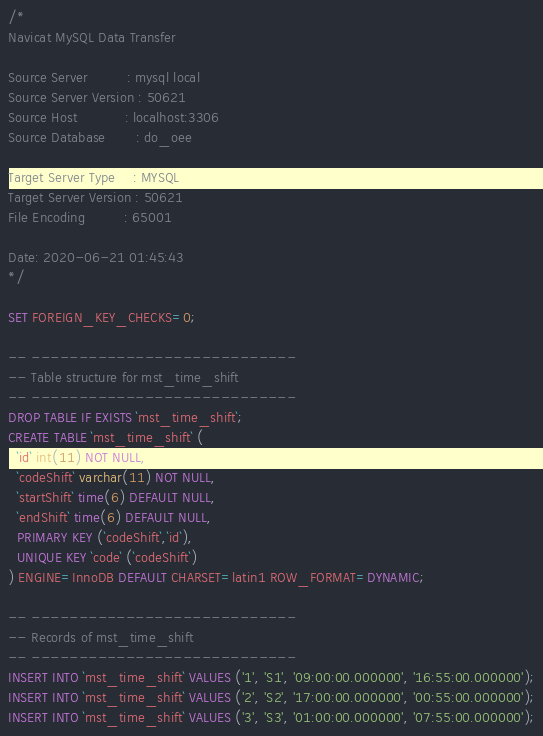Convert code to text. <code><loc_0><loc_0><loc_500><loc_500><_SQL_>/*
Navicat MySQL Data Transfer

Source Server         : mysql local
Source Server Version : 50621
Source Host           : localhost:3306
Source Database       : do_oee

Target Server Type    : MYSQL
Target Server Version : 50621
File Encoding         : 65001

Date: 2020-06-21 01:45:43
*/

SET FOREIGN_KEY_CHECKS=0;

-- ----------------------------
-- Table structure for mst_time_shift
-- ----------------------------
DROP TABLE IF EXISTS `mst_time_shift`;
CREATE TABLE `mst_time_shift` (
  `id` int(11) NOT NULL,
  `codeShift` varchar(11) NOT NULL,
  `startShift` time(6) DEFAULT NULL,
  `endShift` time(6) DEFAULT NULL,
  PRIMARY KEY (`codeShift`,`id`),
  UNIQUE KEY `code` (`codeShift`)
) ENGINE=InnoDB DEFAULT CHARSET=latin1 ROW_FORMAT=DYNAMIC;

-- ----------------------------
-- Records of mst_time_shift
-- ----------------------------
INSERT INTO `mst_time_shift` VALUES ('1', 'S1', '09:00:00.000000', '16:55:00.000000');
INSERT INTO `mst_time_shift` VALUES ('2', 'S2', '17:00:00.000000', '00:55:00.000000');
INSERT INTO `mst_time_shift` VALUES ('3', 'S3', '01:00:00.000000', '07:55:00.000000');
</code> 